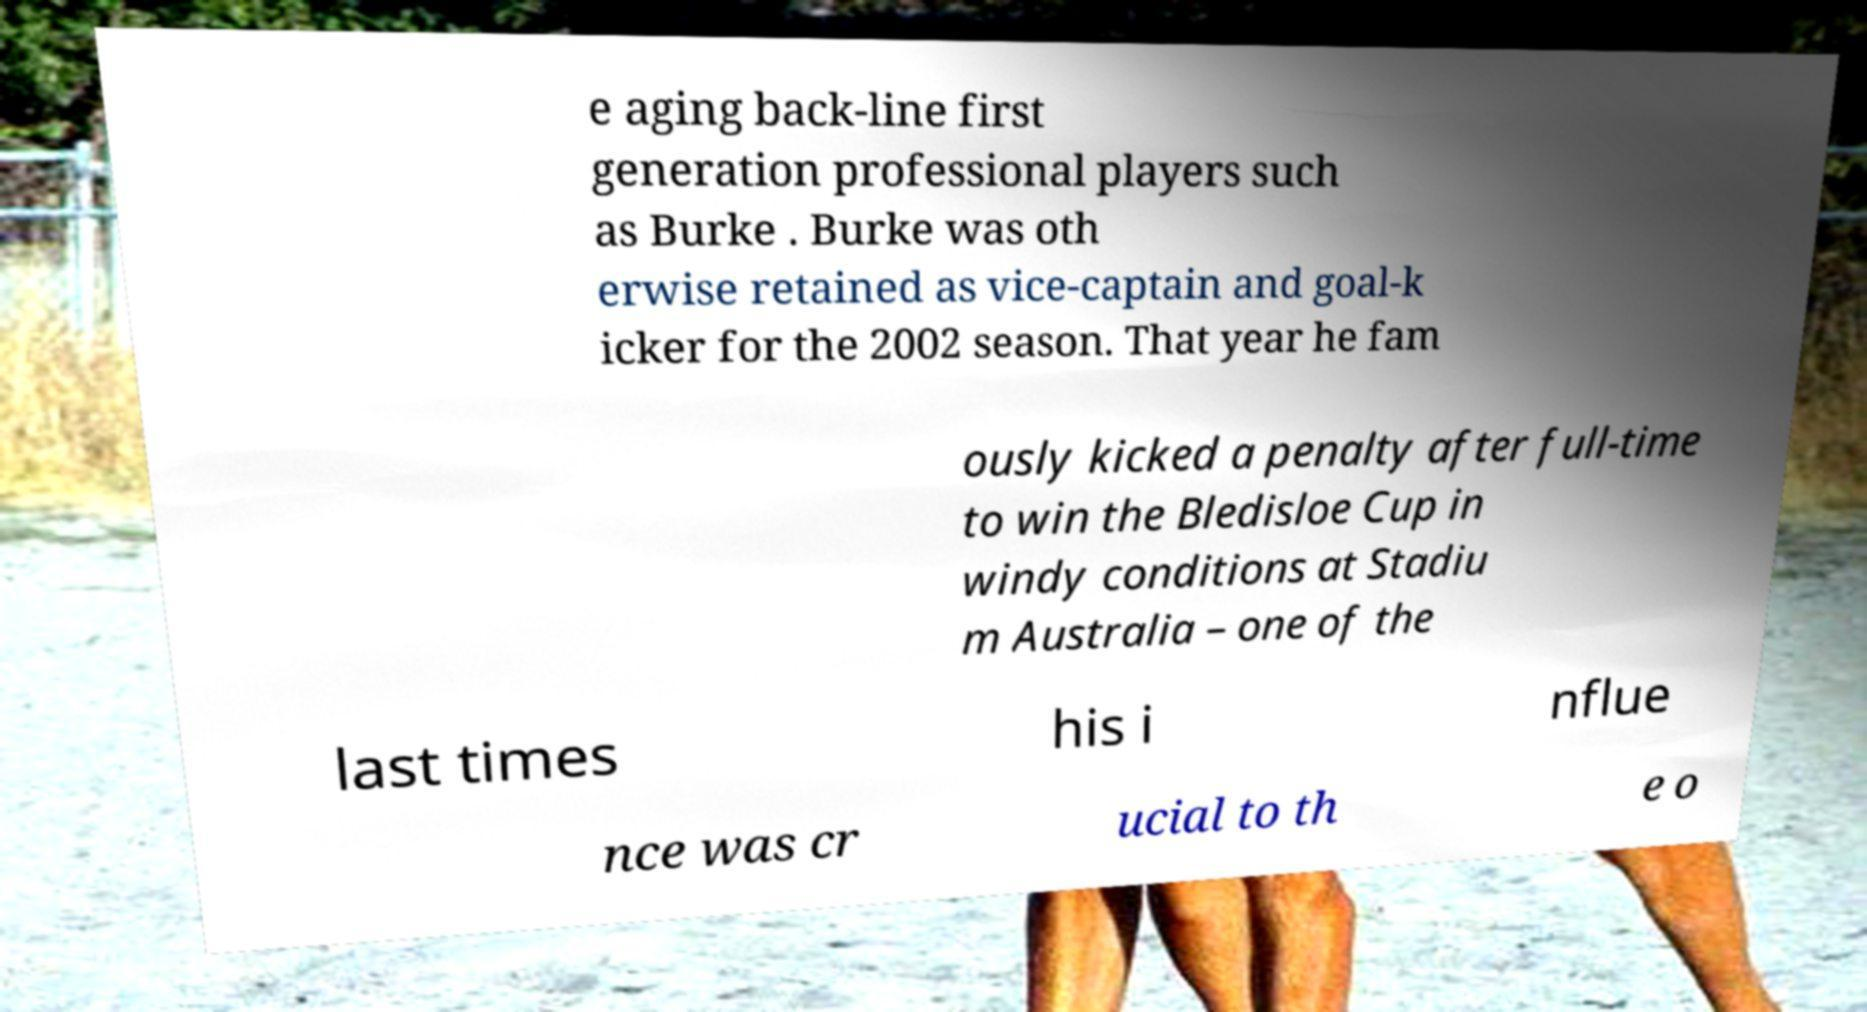Can you accurately transcribe the text from the provided image for me? e aging back-line first generation professional players such as Burke . Burke was oth erwise retained as vice-captain and goal-k icker for the 2002 season. That year he fam ously kicked a penalty after full-time to win the Bledisloe Cup in windy conditions at Stadiu m Australia – one of the last times his i nflue nce was cr ucial to th e o 